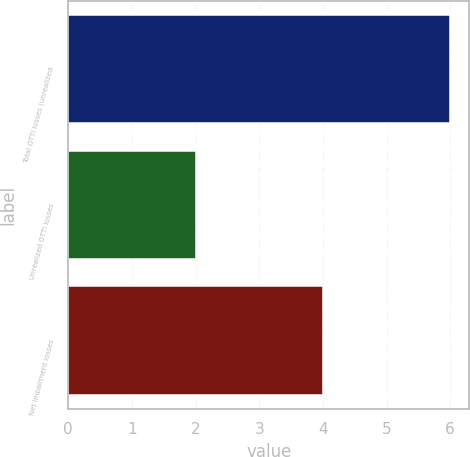Convert chart to OTSL. <chart><loc_0><loc_0><loc_500><loc_500><bar_chart><fcel>Total OTTI losses (unrealized<fcel>Unrealized OTTI losses<fcel>Net impairment losses<nl><fcel>6<fcel>2<fcel>4<nl></chart> 